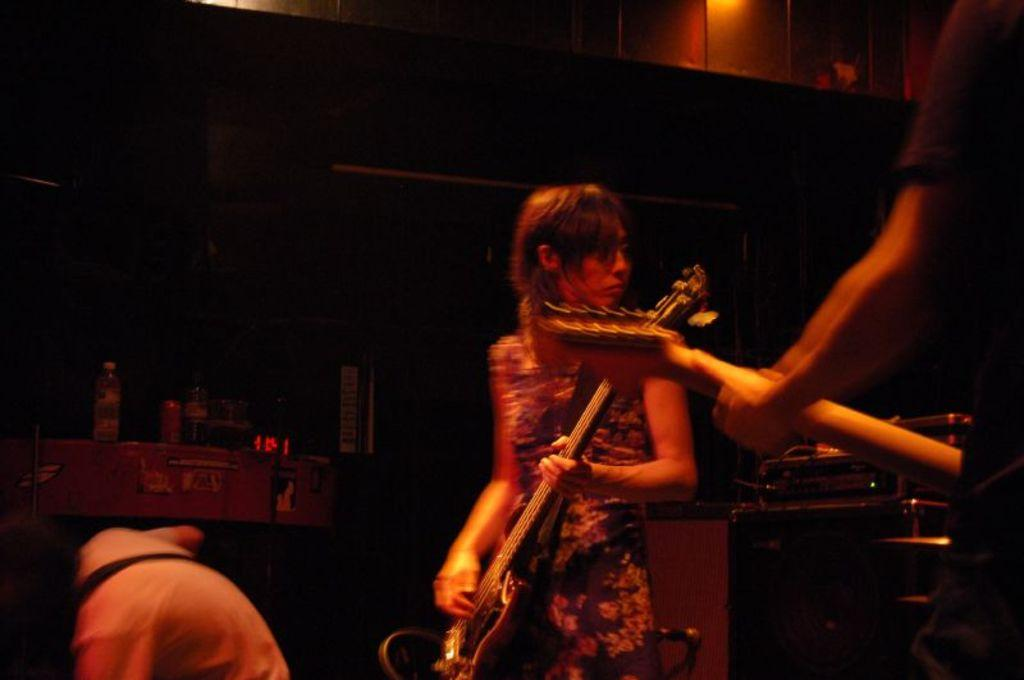How many people are in the image? There are people in the image, but the exact number is not specified. What are the people wearing? The people are wearing clothes. What are two of the people holding? Two people are holding guitars. What other objects can be seen in the image? There is a bottle and a light in the image. What type of scale is being used to weigh the shirts in the image? There is no scale or shirts present in the image. What is the plot of the story being told in the image? The image does not depict a story or plot; it simply shows people, guitars, a bottle, and a light. 